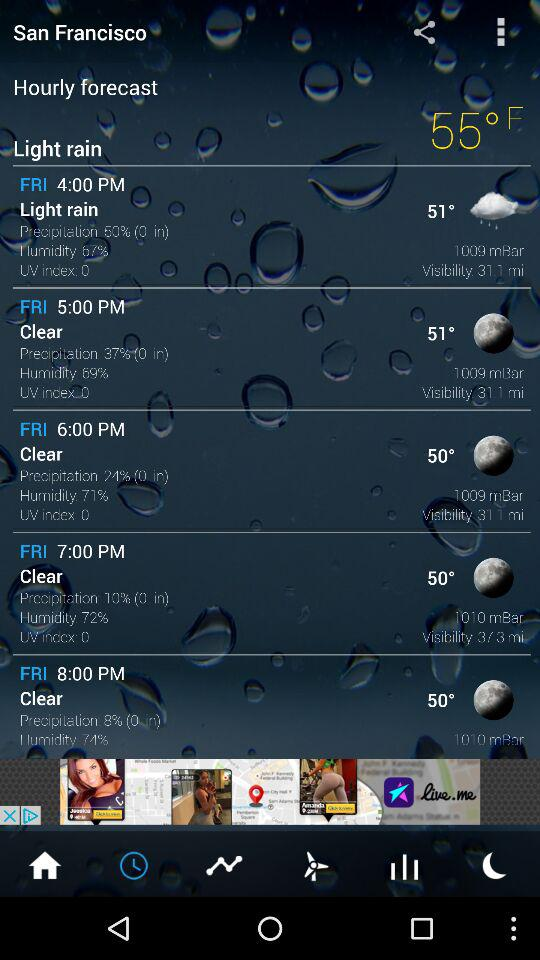What temperature was shown on the screen for Friday at 5:00 pm? The temperature is 51°. 